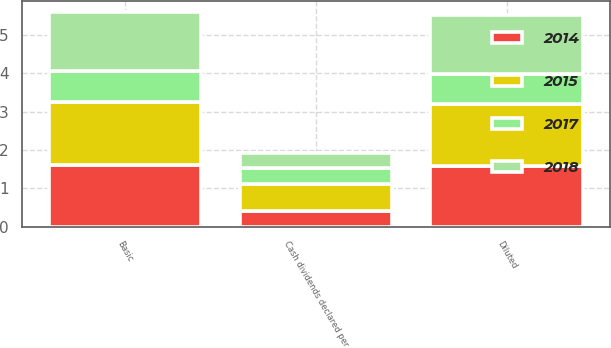Convert chart. <chart><loc_0><loc_0><loc_500><loc_500><stacked_bar_chart><ecel><fcel>Basic<fcel>Diluted<fcel>Cash dividends declared per<nl><fcel>2015<fcel>1.62<fcel>1.6<fcel>0.72<nl><fcel>2017<fcel>0.81<fcel>0.8<fcel>0.4<nl><fcel>2018<fcel>1.55<fcel>1.53<fcel>0.4<nl><fcel>2014<fcel>1.62<fcel>1.59<fcel>0.4<nl></chart> 